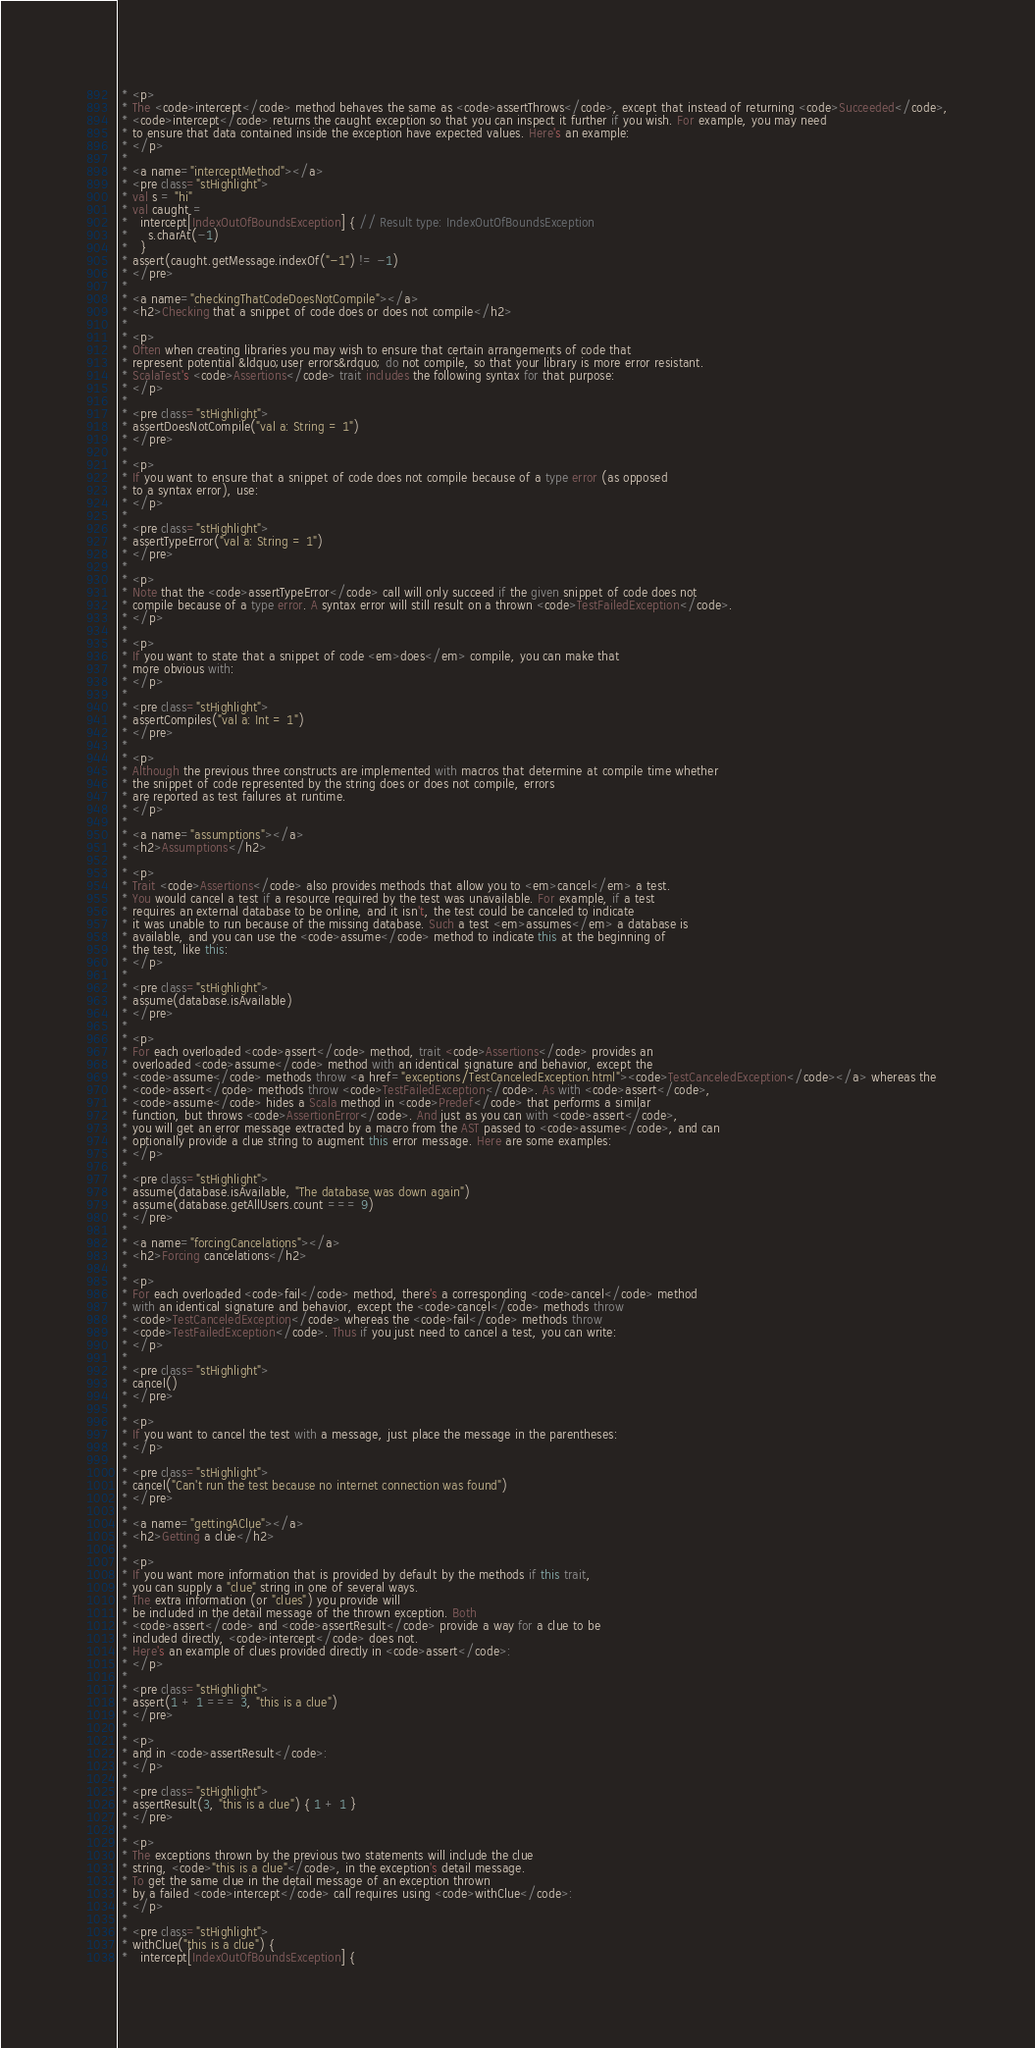Convert code to text. <code><loc_0><loc_0><loc_500><loc_500><_Scala_> * <p>
 * The <code>intercept</code> method behaves the same as <code>assertThrows</code>, except that instead of returning <code>Succeeded</code>,
 * <code>intercept</code> returns the caught exception so that you can inspect it further if you wish. For example, you may need
 * to ensure that data contained inside the exception have expected values. Here's an example:
 * </p>
 *
 * <a name="interceptMethod"></a>
 * <pre class="stHighlight">
 * val s = "hi"
 * val caught =
 *   intercept[IndexOutOfBoundsException] { // Result type: IndexOutOfBoundsException
 *     s.charAt(-1)
 *   }
 * assert(caught.getMessage.indexOf("-1") != -1)
 * </pre>
 *
 * <a name="checkingThatCodeDoesNotCompile"></a>
 * <h2>Checking that a snippet of code does or does not compile</h2>
 *
 * <p>
 * Often when creating libraries you may wish to ensure that certain arrangements of code that
 * represent potential &ldquo;user errors&rdquo; do not compile, so that your library is more error resistant.
 * ScalaTest's <code>Assertions</code> trait includes the following syntax for that purpose:
 * </p>
 *
 * <pre class="stHighlight">
 * assertDoesNotCompile("val a: String = 1")
 * </pre>
 *
 * <p>
 * If you want to ensure that a snippet of code does not compile because of a type error (as opposed
 * to a syntax error), use:
 * </p>
 *
 * <pre class="stHighlight">
 * assertTypeError("val a: String = 1")
 * </pre>
 *
 * <p>
 * Note that the <code>assertTypeError</code> call will only succeed if the given snippet of code does not
 * compile because of a type error. A syntax error will still result on a thrown <code>TestFailedException</code>.
 * </p>
 *
 * <p>
 * If you want to state that a snippet of code <em>does</em> compile, you can make that
 * more obvious with:
 * </p>
 *
 * <pre class="stHighlight">
 * assertCompiles("val a: Int = 1")
 * </pre>
 *
 * <p>
 * Although the previous three constructs are implemented with macros that determine at compile time whether
 * the snippet of code represented by the string does or does not compile, errors
 * are reported as test failures at runtime.
 * </p>
 *
 * <a name="assumptions"></a>
 * <h2>Assumptions</h2>
 *
 * <p>
 * Trait <code>Assertions</code> also provides methods that allow you to <em>cancel</em> a test.
 * You would cancel a test if a resource required by the test was unavailable. For example, if a test
 * requires an external database to be online, and it isn't, the test could be canceled to indicate
 * it was unable to run because of the missing database. Such a test <em>assumes</em> a database is
 * available, and you can use the <code>assume</code> method to indicate this at the beginning of
 * the test, like this:
 * </p>
 *
 * <pre class="stHighlight">
 * assume(database.isAvailable)
 * </pre>
 *
 * <p>
 * For each overloaded <code>assert</code> method, trait <code>Assertions</code> provides an
 * overloaded <code>assume</code> method with an identical signature and behavior, except the
 * <code>assume</code> methods throw <a href="exceptions/TestCanceledException.html"><code>TestCanceledException</code></a> whereas the
 * <code>assert</code> methods throw <code>TestFailedException</code>. As with <code>assert</code>,
 * <code>assume</code> hides a Scala method in <code>Predef</code> that performs a similar
 * function, but throws <code>AssertionError</code>. And just as you can with <code>assert</code>,
 * you will get an error message extracted by a macro from the AST passed to <code>assume</code>, and can
 * optionally provide a clue string to augment this error message. Here are some examples:
 * </p>
 *
 * <pre class="stHighlight">
 * assume(database.isAvailable, "The database was down again")
 * assume(database.getAllUsers.count === 9)
 * </pre>
 *
 * <a name="forcingCancelations"></a>
 * <h2>Forcing cancelations</h2>
 *
 * <p>
 * For each overloaded <code>fail</code> method, there's a corresponding <code>cancel</code> method
 * with an identical signature and behavior, except the <code>cancel</code> methods throw
 * <code>TestCanceledException</code> whereas the <code>fail</code> methods throw
 * <code>TestFailedException</code>. Thus if you just need to cancel a test, you can write:
 * </p>
 *
 * <pre class="stHighlight">
 * cancel()
 * </pre>
 *
 * <p>
 * If you want to cancel the test with a message, just place the message in the parentheses:
 * </p>
 *
 * <pre class="stHighlight">
 * cancel("Can't run the test because no internet connection was found")
 * </pre>
 *
 * <a name="gettingAClue"></a>
 * <h2>Getting a clue</h2>
 *
 * <p>
 * If you want more information that is provided by default by the methods if this trait,
 * you can supply a "clue" string in one of several ways.
 * The extra information (or "clues") you provide will
 * be included in the detail message of the thrown exception. Both
 * <code>assert</code> and <code>assertResult</code> provide a way for a clue to be
 * included directly, <code>intercept</code> does not.
 * Here's an example of clues provided directly in <code>assert</code>:
 * </p>
 *
 * <pre class="stHighlight">
 * assert(1 + 1 === 3, "this is a clue")
 * </pre>
 *
 * <p>
 * and in <code>assertResult</code>:
 * </p>
 *
 * <pre class="stHighlight">
 * assertResult(3, "this is a clue") { 1 + 1 }
 * </pre>
 *
 * <p>
 * The exceptions thrown by the previous two statements will include the clue
 * string, <code>"this is a clue"</code>, in the exception's detail message.
 * To get the same clue in the detail message of an exception thrown
 * by a failed <code>intercept</code> call requires using <code>withClue</code>:
 * </p>
 *
 * <pre class="stHighlight">
 * withClue("this is a clue") {
 *   intercept[IndexOutOfBoundsException] {</code> 